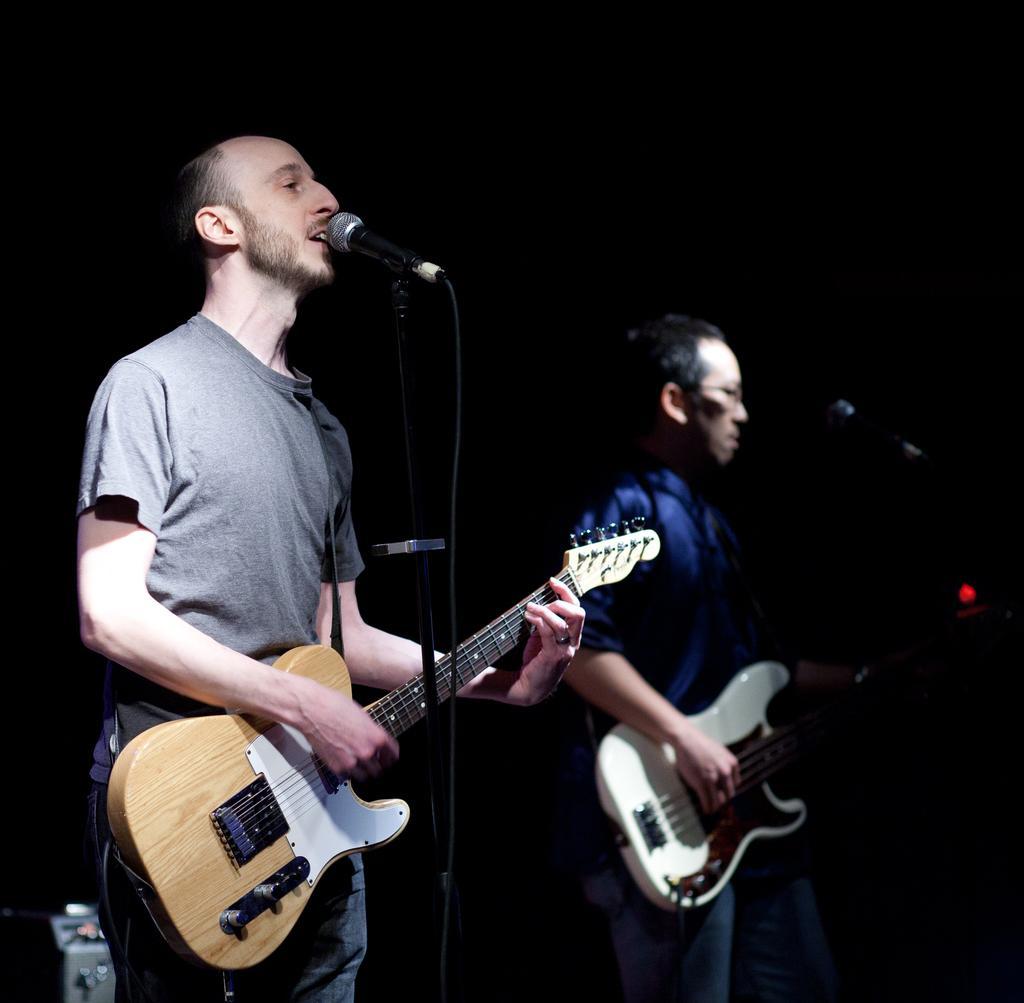Can you describe this image briefly? Background is very dark. Here we can see two men standing in front of a mic , playing guitars and singing. 